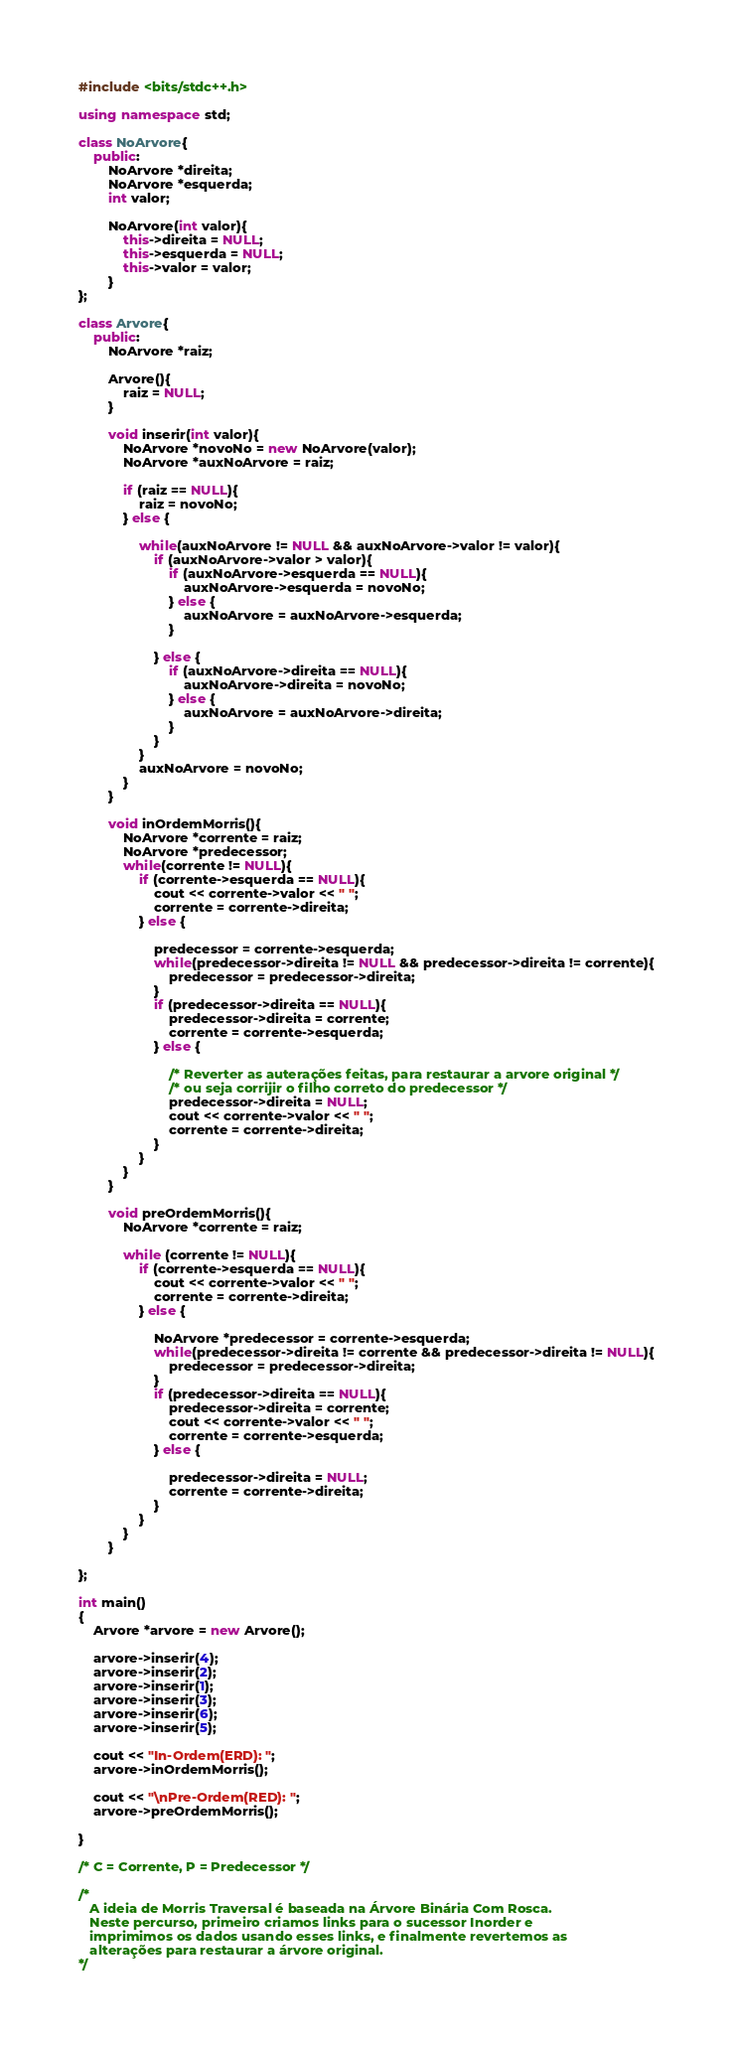<code> <loc_0><loc_0><loc_500><loc_500><_C++_>#include <bits/stdc++.h>

using namespace std;

class NoArvore{
    public:
        NoArvore *direita;
        NoArvore *esquerda;
        int valor;

        NoArvore(int valor){
            this->direita = NULL;
            this->esquerda = NULL;
            this->valor = valor;
        }
};

class Arvore{
    public:
        NoArvore *raiz;

        Arvore(){
            raiz = NULL;
        }

        void inserir(int valor){
            NoArvore *novoNo = new NoArvore(valor);
            NoArvore *auxNoArvore = raiz;  

            if (raiz == NULL){
                raiz = novoNo;
            } else {

                while(auxNoArvore != NULL && auxNoArvore->valor != valor){
                    if (auxNoArvore->valor > valor){
                        if (auxNoArvore->esquerda == NULL){
                            auxNoArvore->esquerda = novoNo;
                        } else {
                            auxNoArvore = auxNoArvore->esquerda;
                        }

                    } else {
                        if (auxNoArvore->direita == NULL){
                            auxNoArvore->direita = novoNo;
                        } else {
                            auxNoArvore = auxNoArvore->direita;
                        }
                    }
                }
                auxNoArvore = novoNo;
            }
        }

        void inOrdemMorris(){
            NoArvore *corrente = raiz;
            NoArvore *predecessor;
            while(corrente != NULL){
                if (corrente->esquerda == NULL){
                    cout << corrente->valor << " ";
                    corrente = corrente->direita;
                } else {
                    
                    predecessor = corrente->esquerda;
                    while(predecessor->direita != NULL && predecessor->direita != corrente){
                        predecessor = predecessor->direita;
                    }
                    if (predecessor->direita == NULL){
                        predecessor->direita = corrente;
                        corrente = corrente->esquerda;
                    } else {

                        /* Reverter as auterações feitas, para restaurar a arvore original */
                        /* ou seja corrijir o filho correto do predecessor */
                        predecessor->direita = NULL;
                        cout << corrente->valor << " ";
                        corrente = corrente->direita;
                    }
                }
            }
        }

        void preOrdemMorris(){
            NoArvore *corrente = raiz;
            
            while (corrente != NULL){
                if (corrente->esquerda == NULL){
                    cout << corrente->valor << " ";
                    corrente = corrente->direita;
                } else {
                    
                    NoArvore *predecessor = corrente->esquerda;
                    while(predecessor->direita != corrente && predecessor->direita != NULL){
                        predecessor = predecessor->direita;
                    }
                    if (predecessor->direita == NULL){
                        predecessor->direita = corrente;
                        cout << corrente->valor << " ";
                        corrente = corrente->esquerda;
                    } else {

                        predecessor->direita = NULL;
                        corrente = corrente->direita;
                    }
                }
            }
        }    
              
};

int main()
{
    Arvore *arvore = new Arvore();

    arvore->inserir(4);
    arvore->inserir(2);
    arvore->inserir(1);
    arvore->inserir(3);
    arvore->inserir(6);
    arvore->inserir(5);

    cout << "In-Ordem(ERD): ";
    arvore->inOrdemMorris();

    cout << "\nPre-Ordem(RED): ";
    arvore->preOrdemMorris();

}

/* C = Corrente, P = Predecessor */

/* 
   A ideia de Morris Traversal é baseada na Árvore Binária Com Rosca.
   Neste percurso, primeiro criamos links para o sucessor Inorder e 
   imprimimos os dados usando esses links, e finalmente revertemos as 
   alterações para restaurar a árvore original.
*/</code> 